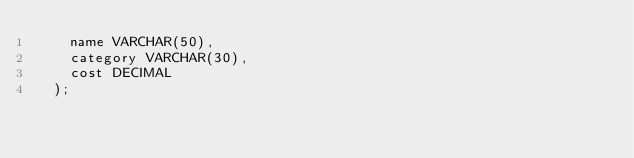Convert code to text. <code><loc_0><loc_0><loc_500><loc_500><_SQL_>    name VARCHAR(50),
    category VARCHAR(30),
    cost DECIMAL
  );</code> 